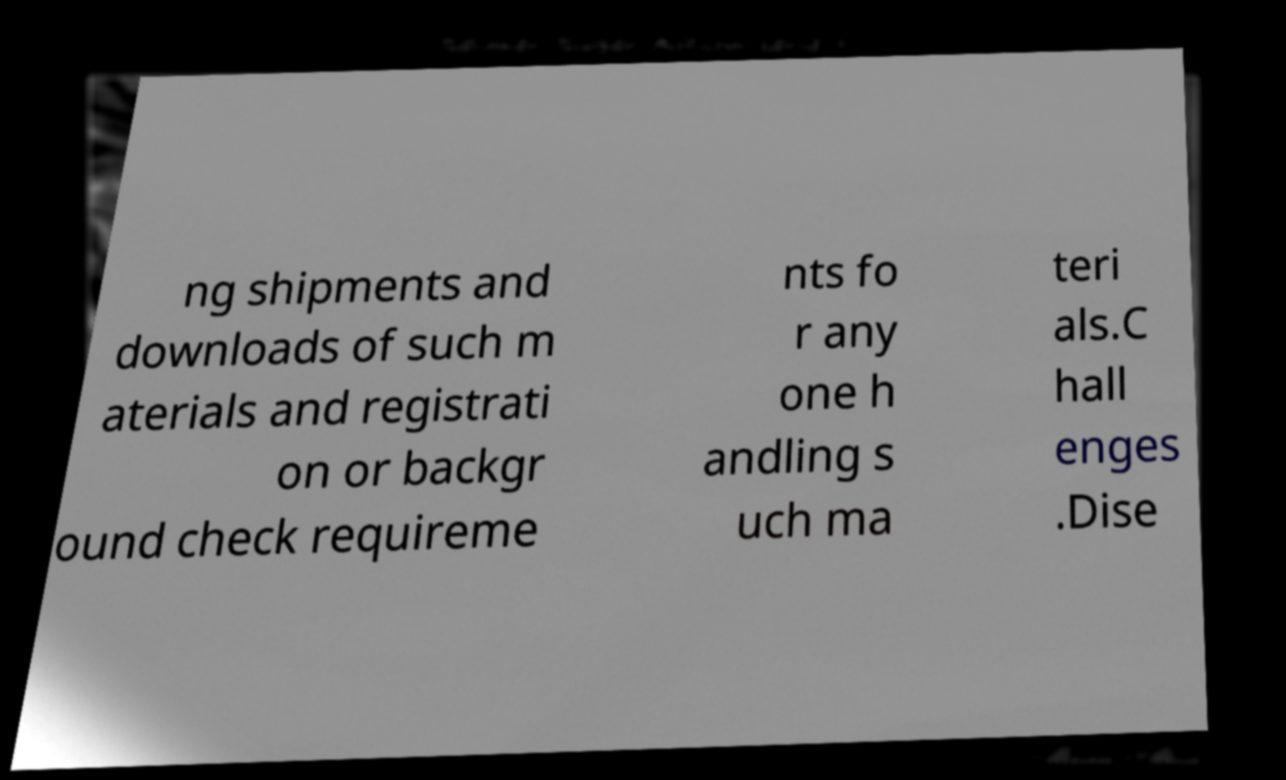Please identify and transcribe the text found in this image. ng shipments and downloads of such m aterials and registrati on or backgr ound check requireme nts fo r any one h andling s uch ma teri als.C hall enges .Dise 